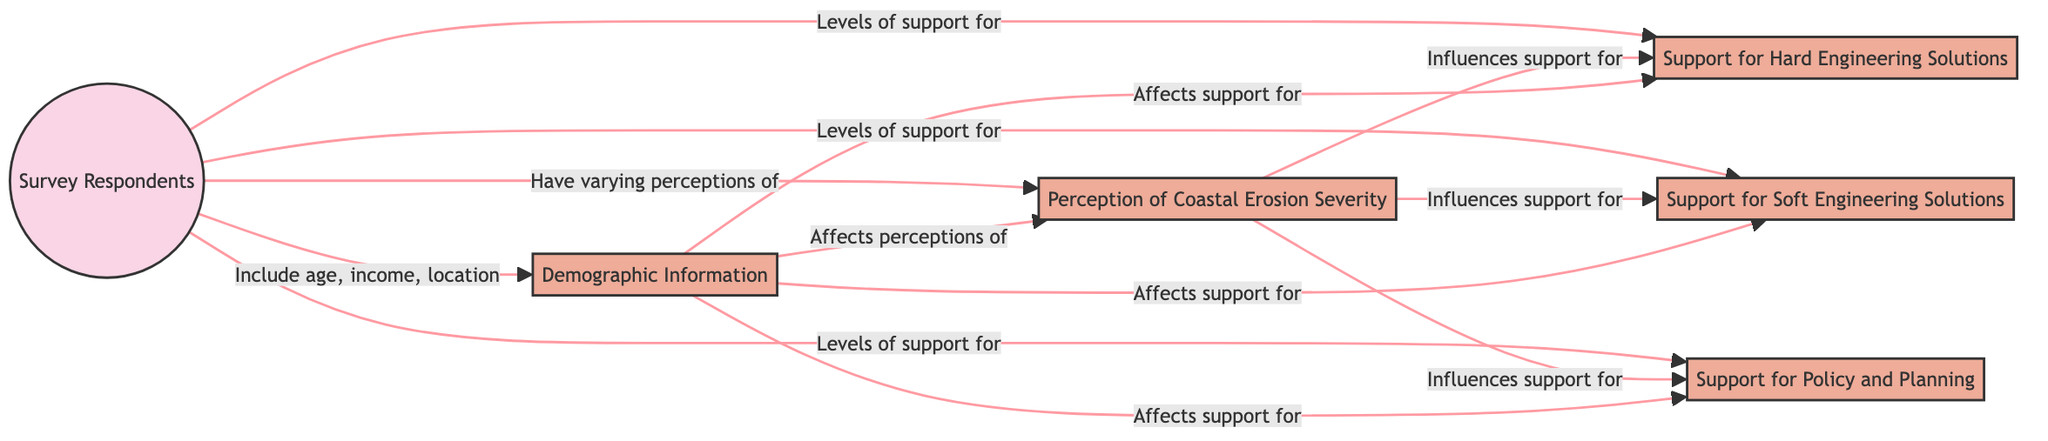What is the central entity in this diagram? The central entity in the diagram is "Survey Respondents," which is represented by the first node and serves as the source of various perceptions and supports for coastal erosion strategies.
Answer: Survey Respondents How many attributes are connected to the main entity? There are four attributes connected to the main entity, namely "Perception of Coastal Erosion Severity," "Support for Hard Engineering Solutions," "Support for Soft Engineering Solutions," and "Support for Policy and Planning."
Answer: Four What influences support for soft engineering solutions? "Perception of Coastal Erosion Severity" influences support for soft engineering solutions, according to the directional arrow connecting these two nodes in the diagram.
Answer: Perception of Coastal Erosion Severity How does demographic information affect perceptions of coastal erosion? The demographic information affects perceptions of coastal erosion by linking directly to "Perception of Coastal Erosion Severity," signifying that factors such as age, income, and location influence how severity is perceived.
Answer: Affects perceptions of Which attribute is affected by both perception of coastal erosion severity and demographic information? "Support for Policy and Planning" is affected by both "Perception of Coastal Erosion Severity" and "Demographic Information," as indicated by the arrows leading to this attribute, showing a correlation to both factors.
Answer: Support for Policy and Planning What type of adaptation supports are mentioned in the diagram? The diagram mentions two types of adaptation supports: "Hard Engineering Solutions" and "Soft Engineering Solutions," illustrating the different approaches offered by respondents.
Answer: Hard Engineering Solutions, Soft Engineering Solutions Is there a direct relationship between demographic information and support for hard engineering solutions? Yes, there is a direct relationship as the diagram shows that demographic information affects support for hard engineering solutions, indicating that demographic factors play a role in influencing this support.
Answer: Yes Which factor has a broad influence over all levels of support outlined in the diagram? "Perception of Coastal Erosion Severity" has a broad influence over all levels of support, affecting both hard and soft engineering solutions, as well as policy and planning support.
Answer: Perception of Coastal Erosion Severity How many types of adaptation strategies are represented in the diagram? There are two types of adaptation strategies represented: "Hard Engineering Solutions" and "Soft Engineering Solutions." Each type has its own level of support within the diagram.
Answer: Two 